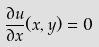Convert formula to latex. <formula><loc_0><loc_0><loc_500><loc_500>\frac { \partial u } { \partial x } ( x , y ) = 0</formula> 